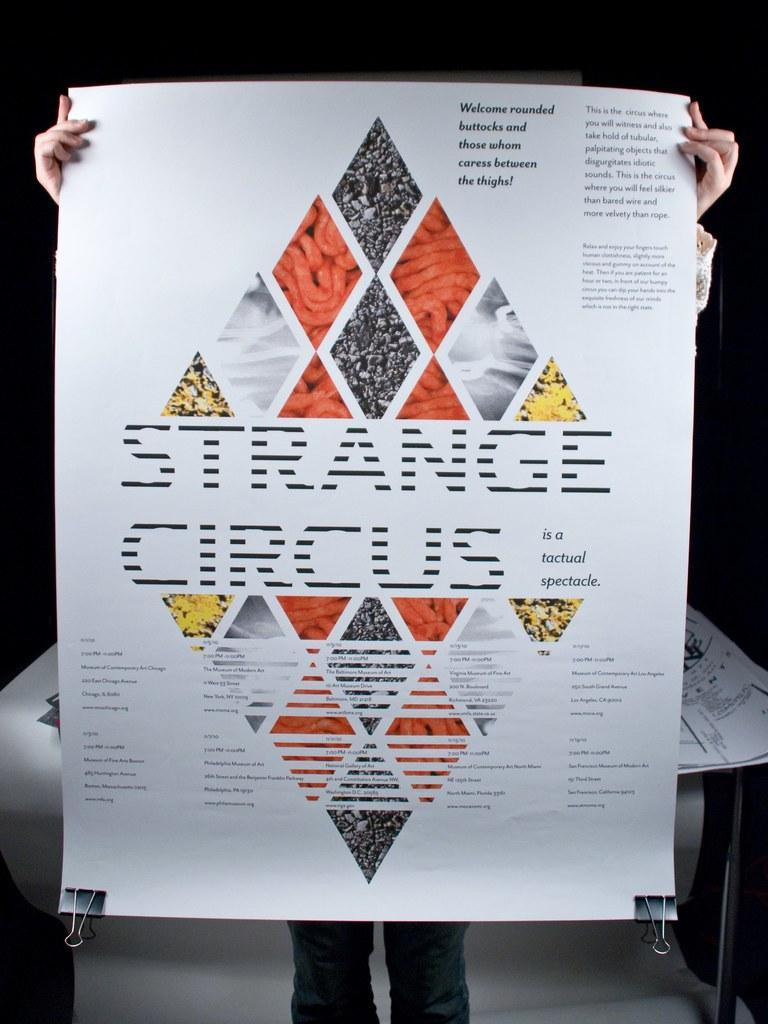Who or what is the main subject in the image? There is a person in the image. What is the person holding in the image? The person is holding a white color poster. Can you describe the poster? There is text on the poster. What is located behind the person in the image? There is a table behind the person. How would you describe the lighting in the image? The background of the image is completely dark. What type of quartz can be seen on the table in the image? There is no quartz present in the image. Is the person holding a poisonous substance on the poster? The text on the poster is not mentioned, so it cannot be determined if it contains any poisonous substance. 